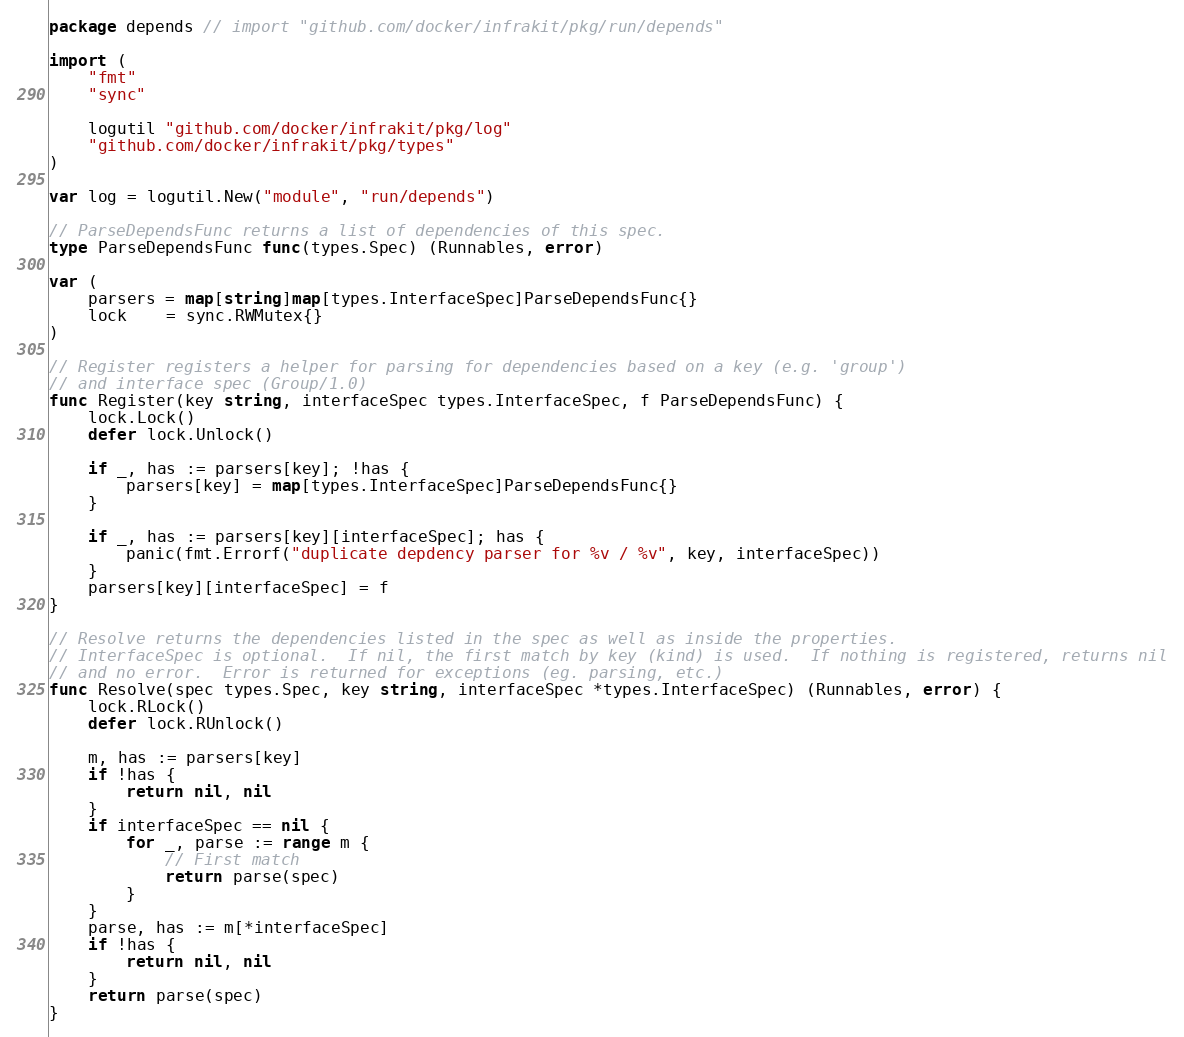<code> <loc_0><loc_0><loc_500><loc_500><_Go_>package depends // import "github.com/docker/infrakit/pkg/run/depends"

import (
	"fmt"
	"sync"

	logutil "github.com/docker/infrakit/pkg/log"
	"github.com/docker/infrakit/pkg/types"
)

var log = logutil.New("module", "run/depends")

// ParseDependsFunc returns a list of dependencies of this spec.
type ParseDependsFunc func(types.Spec) (Runnables, error)

var (
	parsers = map[string]map[types.InterfaceSpec]ParseDependsFunc{}
	lock    = sync.RWMutex{}
)

// Register registers a helper for parsing for dependencies based on a key (e.g. 'group')
// and interface spec (Group/1.0)
func Register(key string, interfaceSpec types.InterfaceSpec, f ParseDependsFunc) {
	lock.Lock()
	defer lock.Unlock()

	if _, has := parsers[key]; !has {
		parsers[key] = map[types.InterfaceSpec]ParseDependsFunc{}
	}

	if _, has := parsers[key][interfaceSpec]; has {
		panic(fmt.Errorf("duplicate depdency parser for %v / %v", key, interfaceSpec))
	}
	parsers[key][interfaceSpec] = f
}

// Resolve returns the dependencies listed in the spec as well as inside the properties.
// InterfaceSpec is optional.  If nil, the first match by key (kind) is used.  If nothing is registered, returns nil
// and no error.  Error is returned for exceptions (eg. parsing, etc.)
func Resolve(spec types.Spec, key string, interfaceSpec *types.InterfaceSpec) (Runnables, error) {
	lock.RLock()
	defer lock.RUnlock()

	m, has := parsers[key]
	if !has {
		return nil, nil
	}
	if interfaceSpec == nil {
		for _, parse := range m {
			// First match
			return parse(spec)
		}
	}
	parse, has := m[*interfaceSpec]
	if !has {
		return nil, nil
	}
	return parse(spec)
}
</code> 